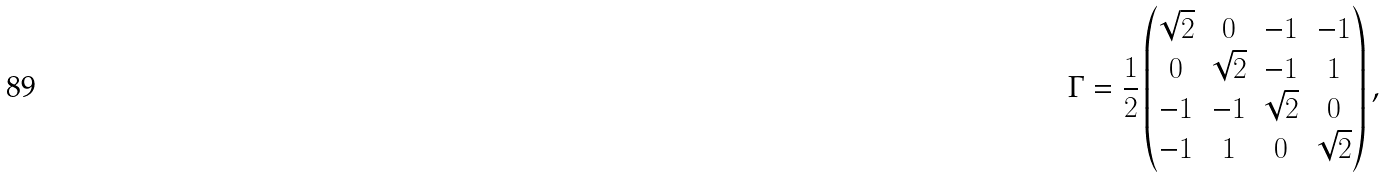Convert formula to latex. <formula><loc_0><loc_0><loc_500><loc_500>\Gamma = \frac { 1 } { 2 } \begin{pmatrix} \sqrt { 2 } & 0 & - 1 & - 1 \\ 0 & \sqrt { 2 } & - 1 & 1 \\ - 1 & - 1 & \sqrt { 2 } & 0 \\ - 1 & 1 & 0 & \sqrt { 2 } \end{pmatrix} ,</formula> 